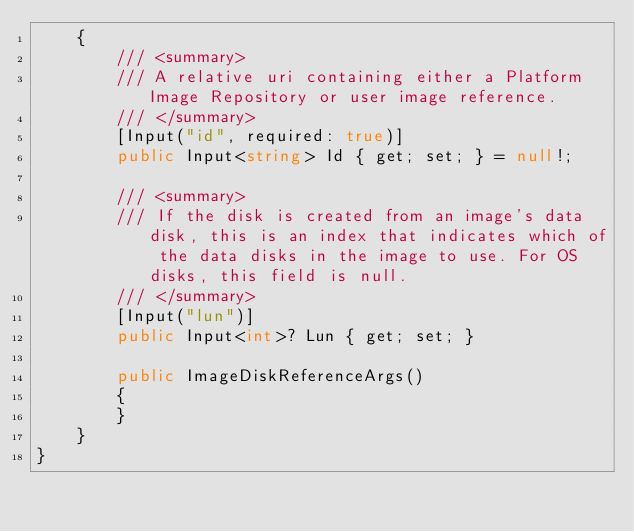<code> <loc_0><loc_0><loc_500><loc_500><_C#_>    {
        /// <summary>
        /// A relative uri containing either a Platform Image Repository or user image reference.
        /// </summary>
        [Input("id", required: true)]
        public Input<string> Id { get; set; } = null!;

        /// <summary>
        /// If the disk is created from an image's data disk, this is an index that indicates which of the data disks in the image to use. For OS disks, this field is null.
        /// </summary>
        [Input("lun")]
        public Input<int>? Lun { get; set; }

        public ImageDiskReferenceArgs()
        {
        }
    }
}
</code> 